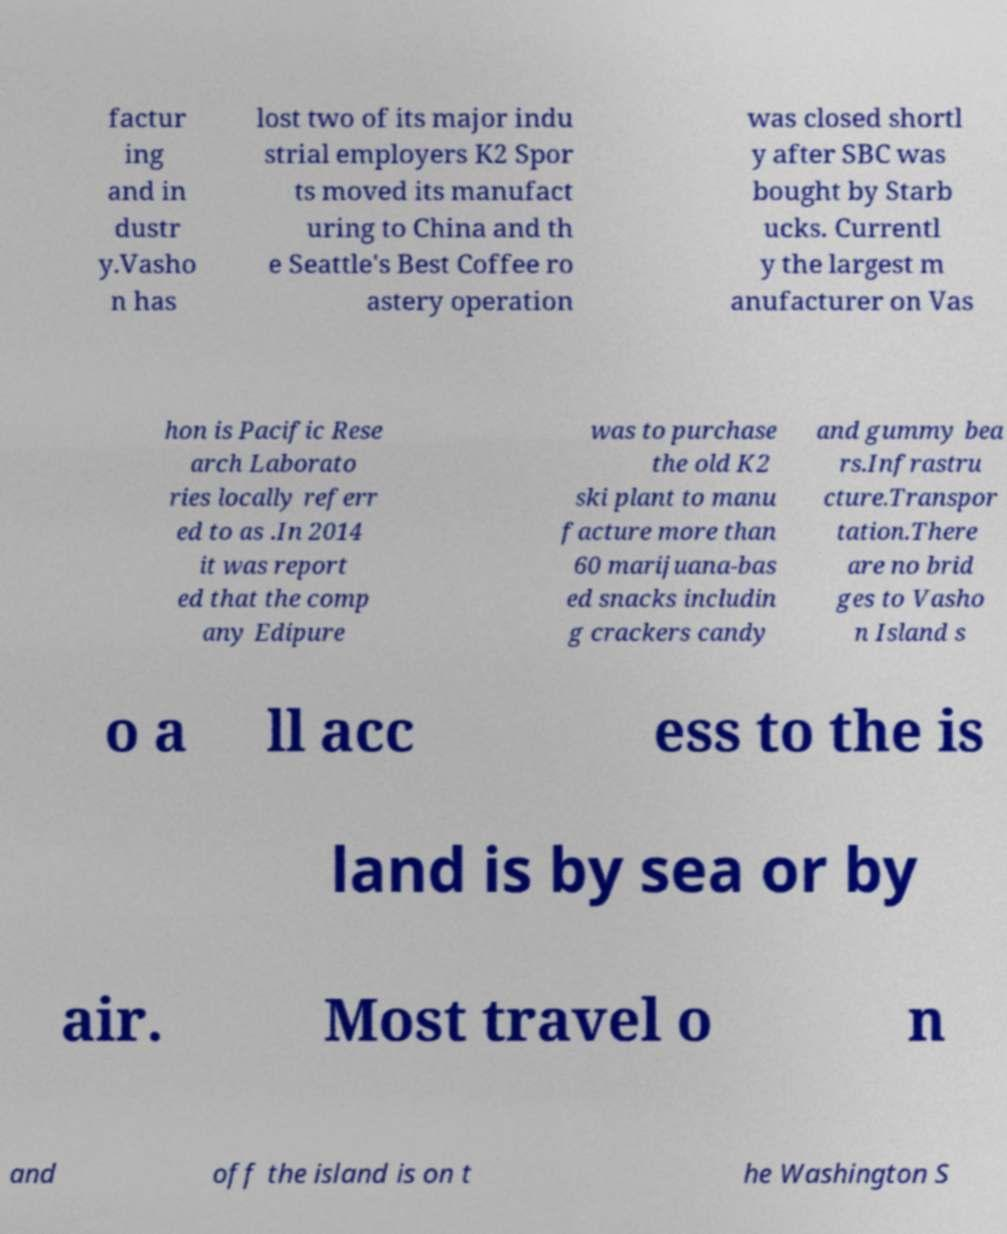What messages or text are displayed in this image? I need them in a readable, typed format. factur ing and in dustr y.Vasho n has lost two of its major indu strial employers K2 Spor ts moved its manufact uring to China and th e Seattle's Best Coffee ro astery operation was closed shortl y after SBC was bought by Starb ucks. Currentl y the largest m anufacturer on Vas hon is Pacific Rese arch Laborato ries locally referr ed to as .In 2014 it was report ed that the comp any Edipure was to purchase the old K2 ski plant to manu facture more than 60 marijuana-bas ed snacks includin g crackers candy and gummy bea rs.Infrastru cture.Transpor tation.There are no brid ges to Vasho n Island s o a ll acc ess to the is land is by sea or by air. Most travel o n and off the island is on t he Washington S 